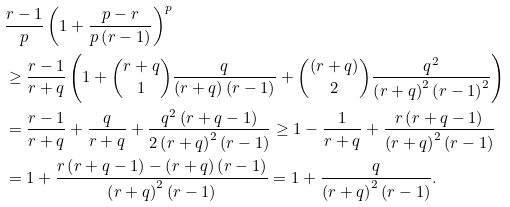<formula> <loc_0><loc_0><loc_500><loc_500>& \frac { r - 1 } { p } \left ( 1 + \frac { p - r } { p \left ( r - 1 \right ) } \right ) ^ { p } \\ & \geq \frac { r - 1 } { r + q } \left ( 1 + \binom { r + q } { 1 } \frac { q } { \left ( r + q \right ) \left ( r - 1 \right ) } + \binom { \left ( r + q \right ) } { 2 } \frac { q ^ { 2 } } { \left ( r + q \right ) ^ { 2 } \left ( r - 1 \right ) ^ { 2 } } \right ) \\ & = \frac { r - 1 } { r + q } + \frac { q } { r + q } + \frac { q ^ { 2 } \left ( r + q - 1 \right ) } { 2 \left ( r + q \right ) ^ { 2 } \left ( r - 1 \right ) } \geq 1 - \frac { 1 } { r + q } + \frac { r \left ( r + q - 1 \right ) } { \left ( r + q \right ) ^ { 2 } \left ( r - 1 \right ) } \\ & = 1 + \frac { r \left ( r + q - 1 \right ) - \left ( r + q \right ) \left ( r - 1 \right ) } { \left ( r + q \right ) ^ { 2 } \left ( r - 1 \right ) } = 1 + \frac { q } { \left ( r + q \right ) ^ { 2 } \left ( r - 1 \right ) } .</formula> 